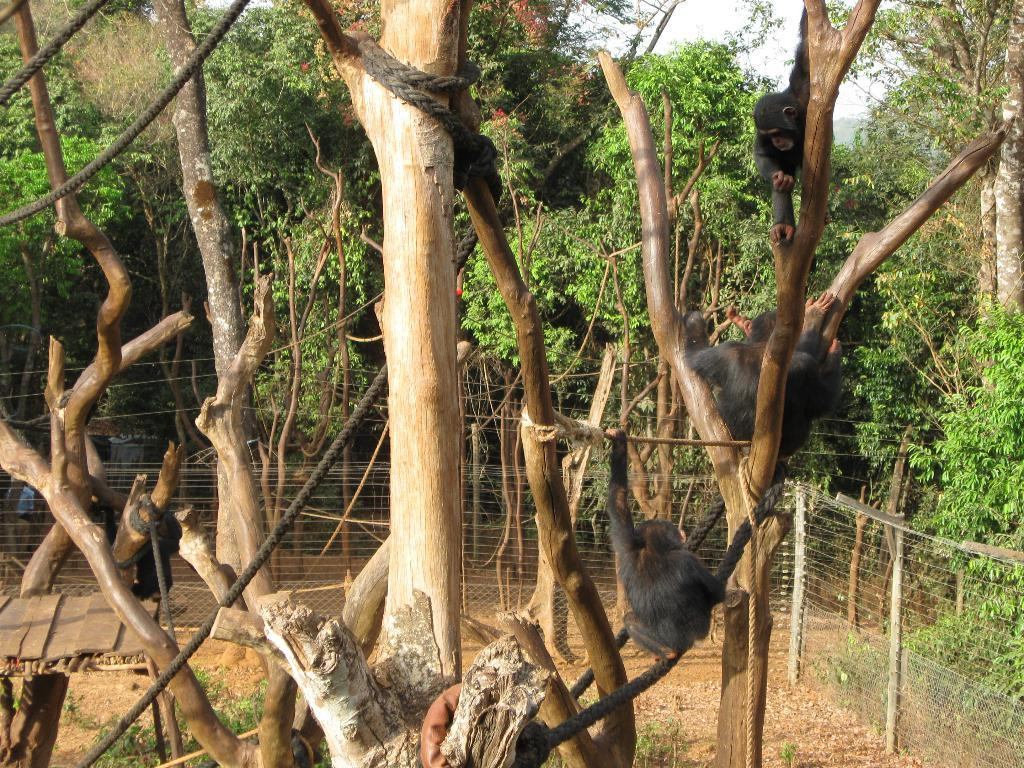What animals can be seen in the image? There are monkeys on the tree in the image. What objects are present in the image besides the monkeys? There are ropes and a fence visible in the image. What can be seen in the background of the image? There are trees in the background of the image. How many balloons are being used for addition in the image? There are no balloons or any indication of addition in the image. 